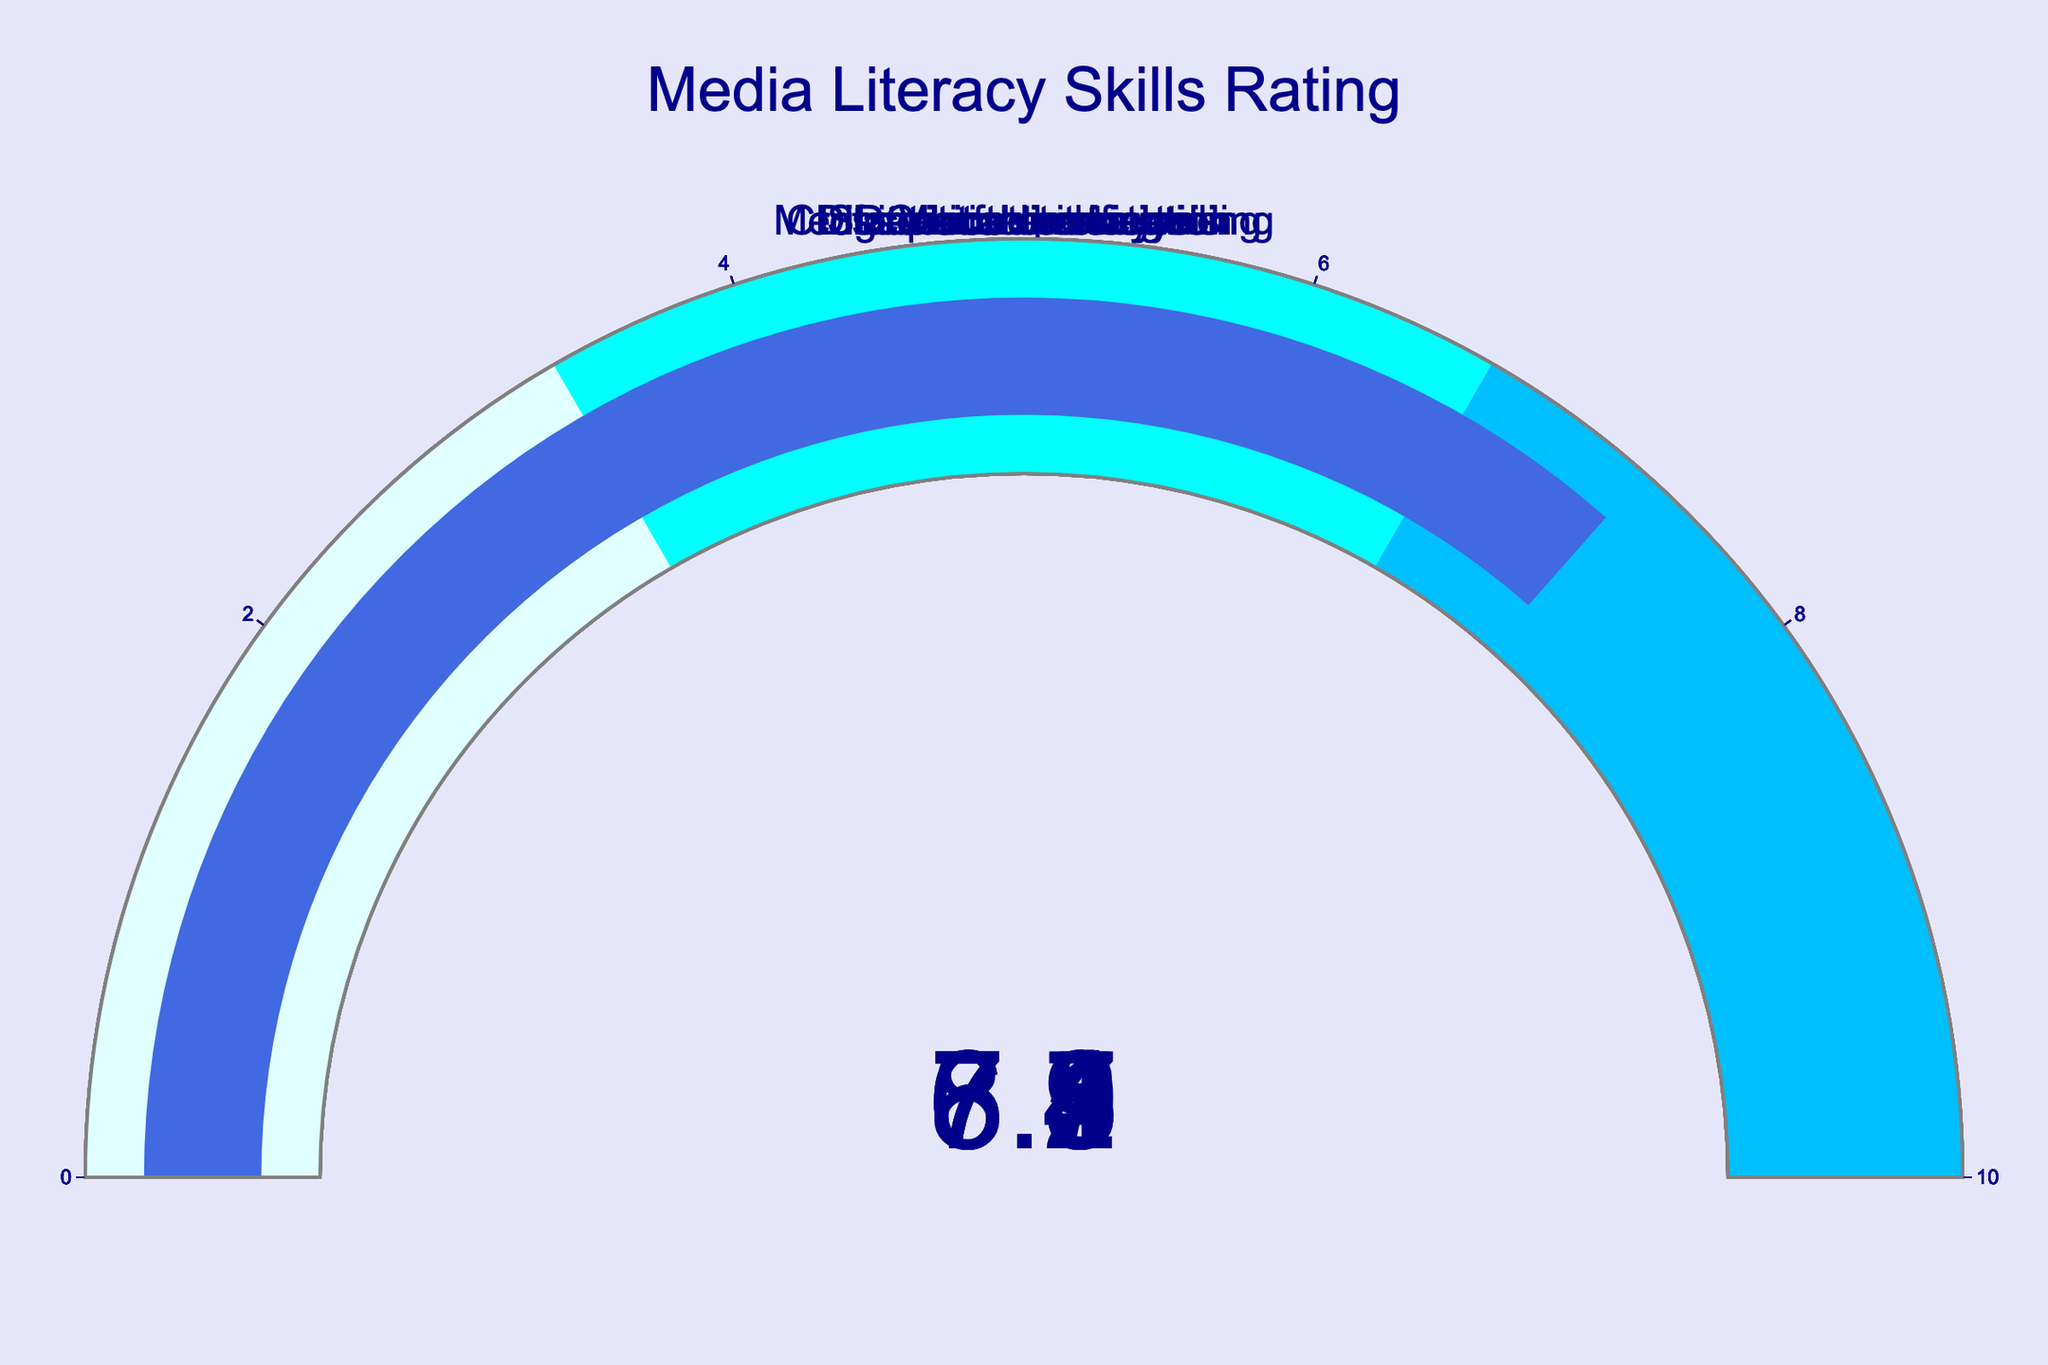What's the skill with the highest rating? The highest rating is observed from the gauge chart displaying the highest value. The 'Social media analysis' skill gauge shows the rating of 8.2, which is the highest among all others.
Answer: Social media analysis What's the skill with the lowest rating? The gauge chart with the lowest value indicates the skill with the lowest rating. 'Media ethics understanding' has a rating of 6.4, which is the lowest among all the skills listed.
Answer: Media ethics understanding How many skills have a rating above 7? To find out how many skills have a rating above 7, visually count the number of gauges showing values greater than 7. 'Critical thinking', 'Social media analysis', 'Information verification', 'Visual literacy', and 'Cross-platform storytelling' have ratings above 7.
Answer: 5 What's the average rating of all skills combined? Sum all the ratings for the given skills (7.5 + 8.2 + 6.9 + 7.1 + 6.4 + 7.8 + 6.7 + 7.3 = 57.9) and divide by the number of skills (8). The calculation gives 57.9 / 8 = 7.24.
Answer: 7.24 Which skills have ratings that fall within the middle range of the gauge (3.33 to 6.66)? To determine which skills fall in the middle range of the gauge, look for the gauges where the indicator lies within the cyan-colored area. 'Digital content creation', 'Media ethics understanding', and 'Data interpretation' all have ratings within 3.33 to 6.66.
Answer: Digital content creation, Media ethics understanding, Data interpretation What’s the difference between the highest and lowest ratings? Identify the values of the highest (8.2 for 'Social media analysis') and lowest (6.4 for 'Media ethics understanding') ratings, then subtract the lowest from the highest: 8.2 - 6.4 = 1.8.
Answer: 1.8 How many skills have a rating below 7? Count the number of gauges with values below 7. 'Digital content creation', 'Media ethics understanding', and 'Data interpretation' show ratings below 7.
Answer: 3 Which rating is closest to the average rating of all skills? The average rating of all skills is 7.24. Visually compare which gauge value is closest to this number. 'Information verification' with 7.1 and 'Cross-platform storytelling' with 7.3 are closest, and since 7.1 is slightly nearer numerically, it is the closest.
Answer: Information verification Which two skills have the smallest rating difference? Compare all neighboring ratings to find the smallest difference. 'Information verification' (7.1) and 'Critical thinking' (7.5) have a difference of 0.4, which is the smallest.
Answer: Information verification, Critical thinking 